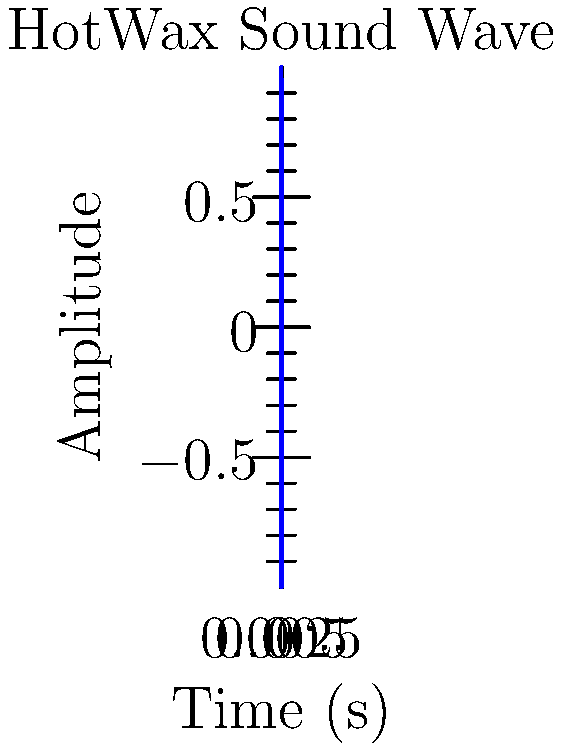As a HotWax superfan, you've been analyzing their latest track's waveform. The graph shows a snippet of the sound wave. If the time axis spans 0.005 seconds and contains 2.2 complete cycles, what is the frequency of this sound wave in Hz? Let's break this down step-by-step:

1) First, we need to understand what frequency means. Frequency is the number of cycles per second, measured in Hz.

2) We're given that the time span is 0.005 seconds, and it contains 2.2 complete cycles.

3) To find the frequency, we need to calculate how many cycles would occur in 1 second:

   $$ \text{Frequency} = \frac{\text{Number of cycles}}{\text{Time span}} $$

4) Let's plug in our values:

   $$ \text{Frequency} = \frac{2.2 \text{ cycles}}{0.005 \text{ seconds}} $$

5) Now, let's calculate:

   $$ \text{Frequency} = 2.2 \div 0.005 = 440 \text{ Hz} $$

This frequency (440 Hz) is actually the standard tuning frequency for the musical note A4, which is commonly used in indie music production.
Answer: 440 Hz 